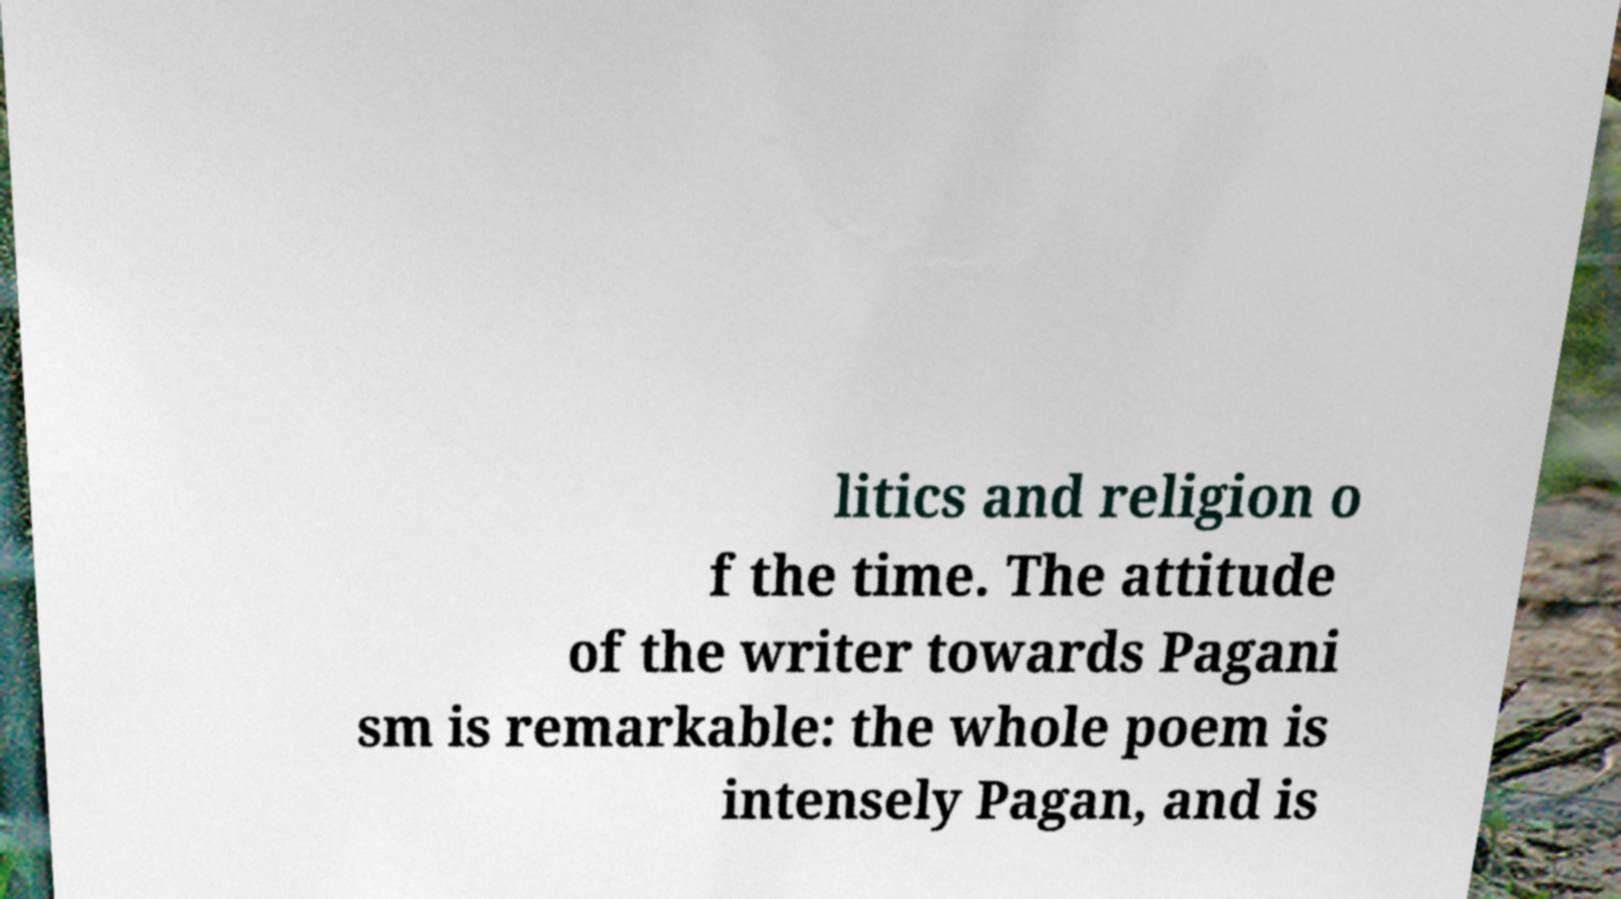What messages or text are displayed in this image? I need them in a readable, typed format. litics and religion o f the time. The attitude of the writer towards Pagani sm is remarkable: the whole poem is intensely Pagan, and is 